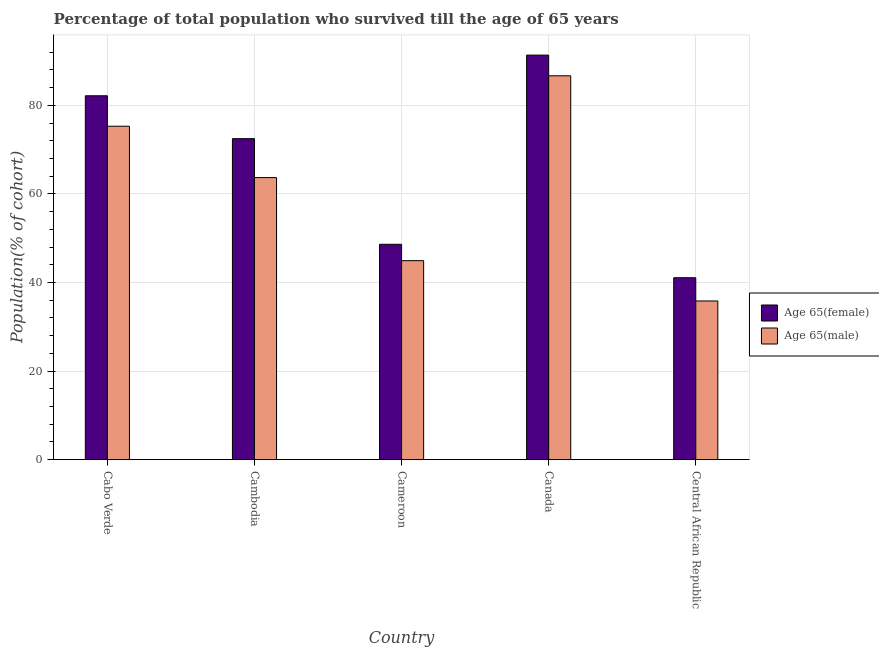How many different coloured bars are there?
Provide a succinct answer. 2. How many groups of bars are there?
Give a very brief answer. 5. What is the label of the 5th group of bars from the left?
Make the answer very short. Central African Republic. What is the percentage of female population who survived till age of 65 in Cambodia?
Your answer should be compact. 72.49. Across all countries, what is the maximum percentage of male population who survived till age of 65?
Your answer should be very brief. 86.69. Across all countries, what is the minimum percentage of female population who survived till age of 65?
Keep it short and to the point. 41.09. In which country was the percentage of male population who survived till age of 65 minimum?
Offer a terse response. Central African Republic. What is the total percentage of male population who survived till age of 65 in the graph?
Give a very brief answer. 306.47. What is the difference between the percentage of female population who survived till age of 65 in Cameroon and that in Canada?
Provide a short and direct response. -42.72. What is the difference between the percentage of male population who survived till age of 65 in Canada and the percentage of female population who survived till age of 65 in Cameroon?
Give a very brief answer. 38.05. What is the average percentage of male population who survived till age of 65 per country?
Make the answer very short. 61.29. What is the difference between the percentage of female population who survived till age of 65 and percentage of male population who survived till age of 65 in Canada?
Your answer should be very brief. 4.67. What is the ratio of the percentage of male population who survived till age of 65 in Cameroon to that in Canada?
Your response must be concise. 0.52. Is the percentage of male population who survived till age of 65 in Cabo Verde less than that in Central African Republic?
Ensure brevity in your answer.  No. What is the difference between the highest and the second highest percentage of female population who survived till age of 65?
Your answer should be compact. 9.18. What is the difference between the highest and the lowest percentage of female population who survived till age of 65?
Make the answer very short. 50.27. What does the 1st bar from the left in Cameroon represents?
Offer a terse response. Age 65(female). What does the 2nd bar from the right in Canada represents?
Offer a terse response. Age 65(female). Are the values on the major ticks of Y-axis written in scientific E-notation?
Provide a short and direct response. No. Does the graph contain any zero values?
Offer a very short reply. No. Where does the legend appear in the graph?
Offer a very short reply. Center right. How are the legend labels stacked?
Your response must be concise. Vertical. What is the title of the graph?
Offer a very short reply. Percentage of total population who survived till the age of 65 years. Does "Diesel" appear as one of the legend labels in the graph?
Provide a succinct answer. No. What is the label or title of the Y-axis?
Make the answer very short. Population(% of cohort). What is the Population(% of cohort) in Age 65(female) in Cabo Verde?
Your response must be concise. 82.17. What is the Population(% of cohort) of Age 65(male) in Cabo Verde?
Your response must be concise. 75.3. What is the Population(% of cohort) in Age 65(female) in Cambodia?
Your answer should be very brief. 72.49. What is the Population(% of cohort) of Age 65(male) in Cambodia?
Make the answer very short. 63.7. What is the Population(% of cohort) in Age 65(female) in Cameroon?
Your answer should be very brief. 48.64. What is the Population(% of cohort) of Age 65(male) in Cameroon?
Your answer should be compact. 44.94. What is the Population(% of cohort) in Age 65(female) in Canada?
Make the answer very short. 91.36. What is the Population(% of cohort) in Age 65(male) in Canada?
Your response must be concise. 86.69. What is the Population(% of cohort) of Age 65(female) in Central African Republic?
Provide a short and direct response. 41.09. What is the Population(% of cohort) of Age 65(male) in Central African Republic?
Offer a very short reply. 35.84. Across all countries, what is the maximum Population(% of cohort) in Age 65(female)?
Provide a short and direct response. 91.36. Across all countries, what is the maximum Population(% of cohort) of Age 65(male)?
Make the answer very short. 86.69. Across all countries, what is the minimum Population(% of cohort) of Age 65(female)?
Keep it short and to the point. 41.09. Across all countries, what is the minimum Population(% of cohort) of Age 65(male)?
Ensure brevity in your answer.  35.84. What is the total Population(% of cohort) of Age 65(female) in the graph?
Keep it short and to the point. 335.75. What is the total Population(% of cohort) in Age 65(male) in the graph?
Make the answer very short. 306.47. What is the difference between the Population(% of cohort) in Age 65(female) in Cabo Verde and that in Cambodia?
Your response must be concise. 9.68. What is the difference between the Population(% of cohort) in Age 65(male) in Cabo Verde and that in Cambodia?
Offer a very short reply. 11.6. What is the difference between the Population(% of cohort) of Age 65(female) in Cabo Verde and that in Cameroon?
Ensure brevity in your answer.  33.53. What is the difference between the Population(% of cohort) in Age 65(male) in Cabo Verde and that in Cameroon?
Your answer should be very brief. 30.35. What is the difference between the Population(% of cohort) in Age 65(female) in Cabo Verde and that in Canada?
Your response must be concise. -9.18. What is the difference between the Population(% of cohort) of Age 65(male) in Cabo Verde and that in Canada?
Your response must be concise. -11.39. What is the difference between the Population(% of cohort) of Age 65(female) in Cabo Verde and that in Central African Republic?
Offer a very short reply. 41.08. What is the difference between the Population(% of cohort) in Age 65(male) in Cabo Verde and that in Central African Republic?
Make the answer very short. 39.45. What is the difference between the Population(% of cohort) in Age 65(female) in Cambodia and that in Cameroon?
Your response must be concise. 23.85. What is the difference between the Population(% of cohort) in Age 65(male) in Cambodia and that in Cameroon?
Provide a short and direct response. 18.76. What is the difference between the Population(% of cohort) of Age 65(female) in Cambodia and that in Canada?
Your response must be concise. -18.87. What is the difference between the Population(% of cohort) of Age 65(male) in Cambodia and that in Canada?
Offer a very short reply. -22.99. What is the difference between the Population(% of cohort) in Age 65(female) in Cambodia and that in Central African Republic?
Provide a short and direct response. 31.4. What is the difference between the Population(% of cohort) of Age 65(male) in Cambodia and that in Central African Republic?
Provide a succinct answer. 27.86. What is the difference between the Population(% of cohort) of Age 65(female) in Cameroon and that in Canada?
Ensure brevity in your answer.  -42.72. What is the difference between the Population(% of cohort) of Age 65(male) in Cameroon and that in Canada?
Make the answer very short. -41.74. What is the difference between the Population(% of cohort) in Age 65(female) in Cameroon and that in Central African Republic?
Your answer should be very brief. 7.55. What is the difference between the Population(% of cohort) of Age 65(male) in Cameroon and that in Central African Republic?
Your answer should be compact. 9.1. What is the difference between the Population(% of cohort) of Age 65(female) in Canada and that in Central African Republic?
Ensure brevity in your answer.  50.27. What is the difference between the Population(% of cohort) in Age 65(male) in Canada and that in Central African Republic?
Offer a terse response. 50.84. What is the difference between the Population(% of cohort) in Age 65(female) in Cabo Verde and the Population(% of cohort) in Age 65(male) in Cambodia?
Offer a terse response. 18.47. What is the difference between the Population(% of cohort) of Age 65(female) in Cabo Verde and the Population(% of cohort) of Age 65(male) in Cameroon?
Offer a terse response. 37.23. What is the difference between the Population(% of cohort) of Age 65(female) in Cabo Verde and the Population(% of cohort) of Age 65(male) in Canada?
Offer a terse response. -4.51. What is the difference between the Population(% of cohort) of Age 65(female) in Cabo Verde and the Population(% of cohort) of Age 65(male) in Central African Republic?
Offer a terse response. 46.33. What is the difference between the Population(% of cohort) of Age 65(female) in Cambodia and the Population(% of cohort) of Age 65(male) in Cameroon?
Keep it short and to the point. 27.55. What is the difference between the Population(% of cohort) of Age 65(female) in Cambodia and the Population(% of cohort) of Age 65(male) in Canada?
Offer a terse response. -14.2. What is the difference between the Population(% of cohort) of Age 65(female) in Cambodia and the Population(% of cohort) of Age 65(male) in Central African Republic?
Your answer should be very brief. 36.65. What is the difference between the Population(% of cohort) of Age 65(female) in Cameroon and the Population(% of cohort) of Age 65(male) in Canada?
Provide a short and direct response. -38.05. What is the difference between the Population(% of cohort) in Age 65(female) in Cameroon and the Population(% of cohort) in Age 65(male) in Central African Republic?
Give a very brief answer. 12.8. What is the difference between the Population(% of cohort) of Age 65(female) in Canada and the Population(% of cohort) of Age 65(male) in Central African Republic?
Your response must be concise. 55.52. What is the average Population(% of cohort) in Age 65(female) per country?
Give a very brief answer. 67.15. What is the average Population(% of cohort) in Age 65(male) per country?
Keep it short and to the point. 61.29. What is the difference between the Population(% of cohort) in Age 65(female) and Population(% of cohort) in Age 65(male) in Cabo Verde?
Your answer should be compact. 6.88. What is the difference between the Population(% of cohort) in Age 65(female) and Population(% of cohort) in Age 65(male) in Cambodia?
Your answer should be very brief. 8.79. What is the difference between the Population(% of cohort) in Age 65(female) and Population(% of cohort) in Age 65(male) in Cameroon?
Make the answer very short. 3.69. What is the difference between the Population(% of cohort) in Age 65(female) and Population(% of cohort) in Age 65(male) in Canada?
Your answer should be very brief. 4.67. What is the difference between the Population(% of cohort) in Age 65(female) and Population(% of cohort) in Age 65(male) in Central African Republic?
Offer a very short reply. 5.25. What is the ratio of the Population(% of cohort) of Age 65(female) in Cabo Verde to that in Cambodia?
Your answer should be very brief. 1.13. What is the ratio of the Population(% of cohort) in Age 65(male) in Cabo Verde to that in Cambodia?
Provide a succinct answer. 1.18. What is the ratio of the Population(% of cohort) in Age 65(female) in Cabo Verde to that in Cameroon?
Keep it short and to the point. 1.69. What is the ratio of the Population(% of cohort) in Age 65(male) in Cabo Verde to that in Cameroon?
Provide a succinct answer. 1.68. What is the ratio of the Population(% of cohort) in Age 65(female) in Cabo Verde to that in Canada?
Ensure brevity in your answer.  0.9. What is the ratio of the Population(% of cohort) of Age 65(male) in Cabo Verde to that in Canada?
Your answer should be compact. 0.87. What is the ratio of the Population(% of cohort) of Age 65(female) in Cabo Verde to that in Central African Republic?
Provide a succinct answer. 2. What is the ratio of the Population(% of cohort) in Age 65(male) in Cabo Verde to that in Central African Republic?
Provide a short and direct response. 2.1. What is the ratio of the Population(% of cohort) in Age 65(female) in Cambodia to that in Cameroon?
Your answer should be compact. 1.49. What is the ratio of the Population(% of cohort) in Age 65(male) in Cambodia to that in Cameroon?
Offer a very short reply. 1.42. What is the ratio of the Population(% of cohort) of Age 65(female) in Cambodia to that in Canada?
Provide a succinct answer. 0.79. What is the ratio of the Population(% of cohort) in Age 65(male) in Cambodia to that in Canada?
Your response must be concise. 0.73. What is the ratio of the Population(% of cohort) in Age 65(female) in Cambodia to that in Central African Republic?
Make the answer very short. 1.76. What is the ratio of the Population(% of cohort) in Age 65(male) in Cambodia to that in Central African Republic?
Make the answer very short. 1.78. What is the ratio of the Population(% of cohort) of Age 65(female) in Cameroon to that in Canada?
Your answer should be very brief. 0.53. What is the ratio of the Population(% of cohort) in Age 65(male) in Cameroon to that in Canada?
Your response must be concise. 0.52. What is the ratio of the Population(% of cohort) of Age 65(female) in Cameroon to that in Central African Republic?
Give a very brief answer. 1.18. What is the ratio of the Population(% of cohort) of Age 65(male) in Cameroon to that in Central African Republic?
Offer a terse response. 1.25. What is the ratio of the Population(% of cohort) in Age 65(female) in Canada to that in Central African Republic?
Your answer should be very brief. 2.22. What is the ratio of the Population(% of cohort) of Age 65(male) in Canada to that in Central African Republic?
Keep it short and to the point. 2.42. What is the difference between the highest and the second highest Population(% of cohort) in Age 65(female)?
Provide a short and direct response. 9.18. What is the difference between the highest and the second highest Population(% of cohort) of Age 65(male)?
Give a very brief answer. 11.39. What is the difference between the highest and the lowest Population(% of cohort) in Age 65(female)?
Your response must be concise. 50.27. What is the difference between the highest and the lowest Population(% of cohort) of Age 65(male)?
Provide a short and direct response. 50.84. 